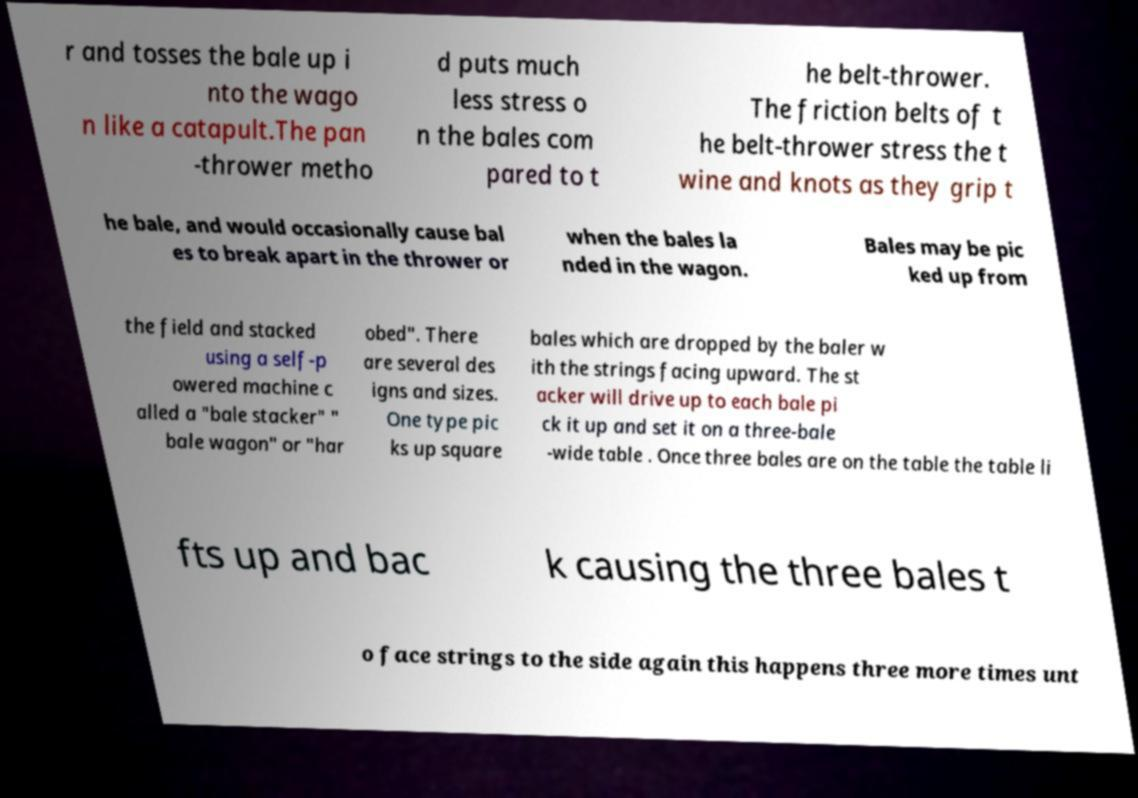I need the written content from this picture converted into text. Can you do that? r and tosses the bale up i nto the wago n like a catapult.The pan -thrower metho d puts much less stress o n the bales com pared to t he belt-thrower. The friction belts of t he belt-thrower stress the t wine and knots as they grip t he bale, and would occasionally cause bal es to break apart in the thrower or when the bales la nded in the wagon. Bales may be pic ked up from the field and stacked using a self-p owered machine c alled a "bale stacker" " bale wagon" or "har obed". There are several des igns and sizes. One type pic ks up square bales which are dropped by the baler w ith the strings facing upward. The st acker will drive up to each bale pi ck it up and set it on a three-bale -wide table . Once three bales are on the table the table li fts up and bac k causing the three bales t o face strings to the side again this happens three more times unt 